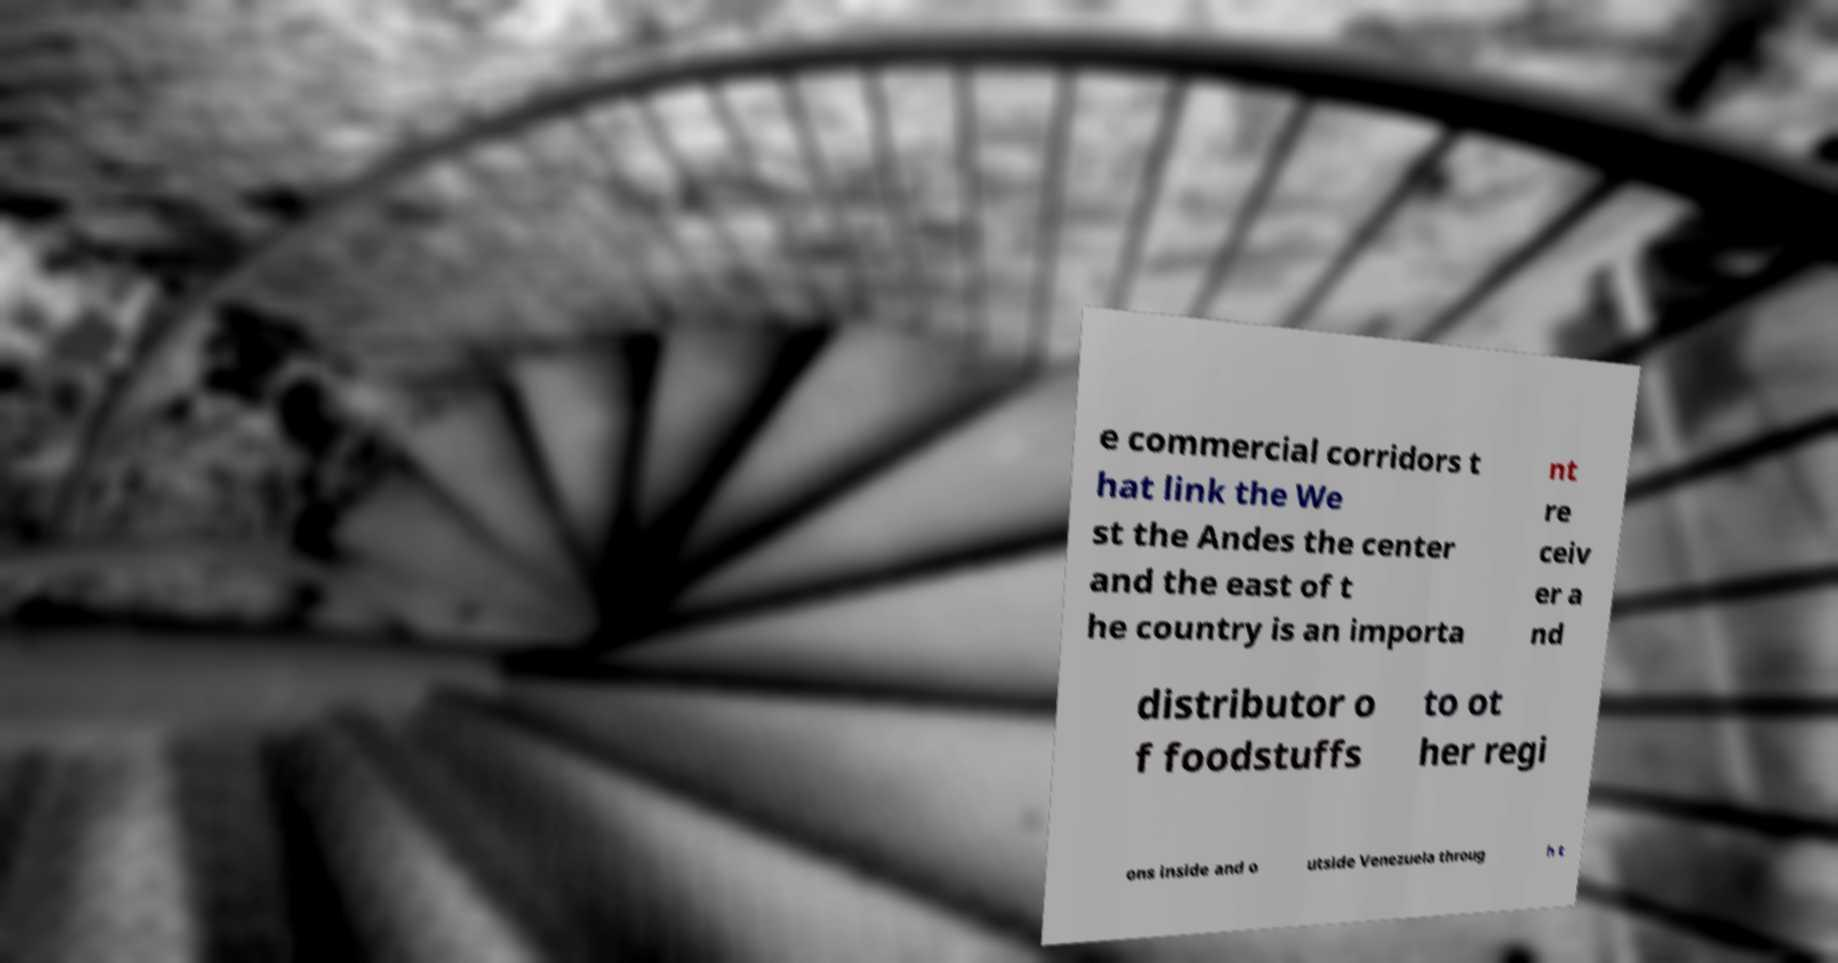Could you assist in decoding the text presented in this image and type it out clearly? e commercial corridors t hat link the We st the Andes the center and the east of t he country is an importa nt re ceiv er a nd distributor o f foodstuffs to ot her regi ons inside and o utside Venezuela throug h t 